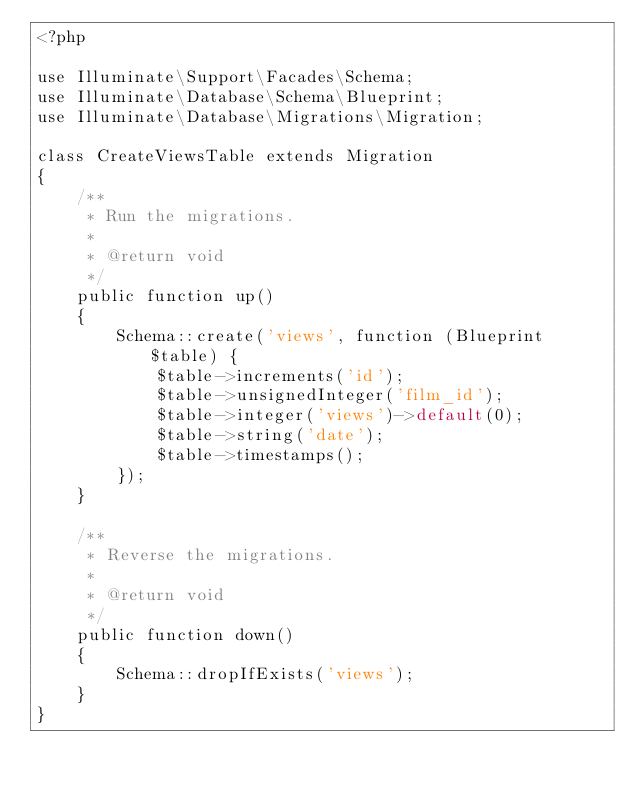Convert code to text. <code><loc_0><loc_0><loc_500><loc_500><_PHP_><?php

use Illuminate\Support\Facades\Schema;
use Illuminate\Database\Schema\Blueprint;
use Illuminate\Database\Migrations\Migration;

class CreateViewsTable extends Migration
{
    /**
     * Run the migrations.
     *
     * @return void
     */
    public function up()
    {
        Schema::create('views', function (Blueprint $table) {
            $table->increments('id');
            $table->unsignedInteger('film_id');
            $table->integer('views')->default(0);
            $table->string('date');
            $table->timestamps();
        });
    }

    /**
     * Reverse the migrations.
     *
     * @return void
     */
    public function down()
    {
        Schema::dropIfExists('views');
    }
}
</code> 